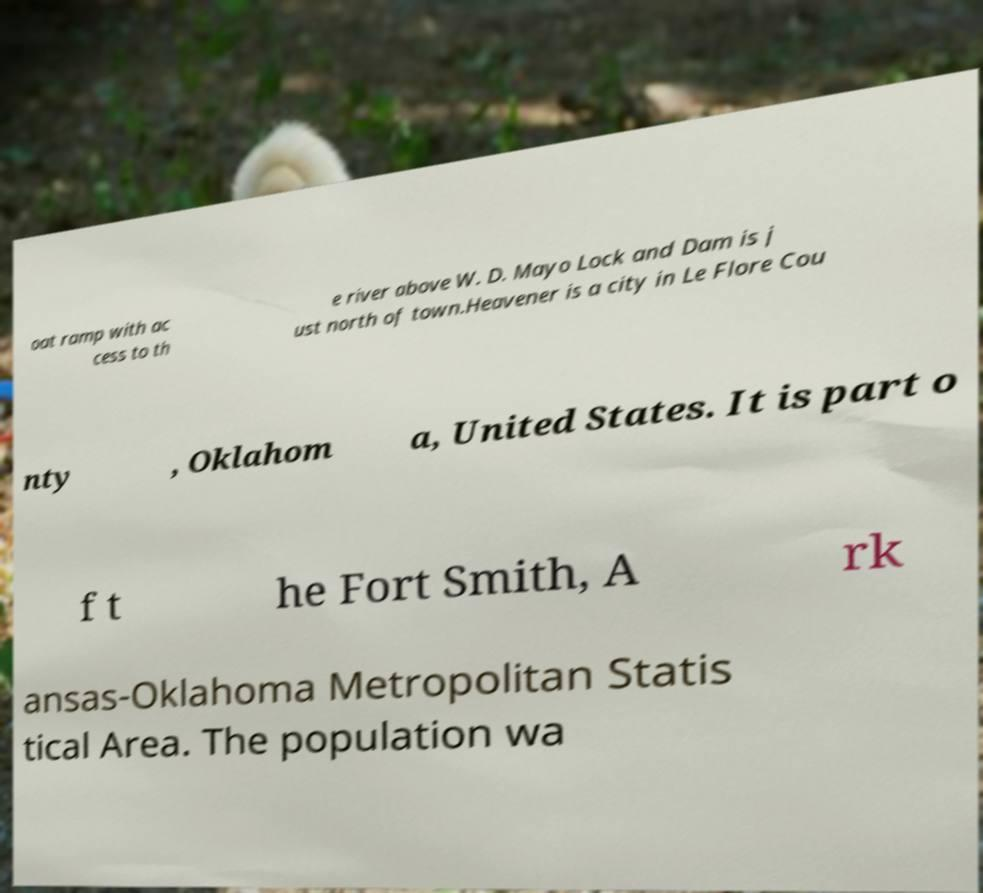Please read and relay the text visible in this image. What does it say? oat ramp with ac cess to th e river above W. D. Mayo Lock and Dam is j ust north of town.Heavener is a city in Le Flore Cou nty , Oklahom a, United States. It is part o f t he Fort Smith, A rk ansas-Oklahoma Metropolitan Statis tical Area. The population wa 